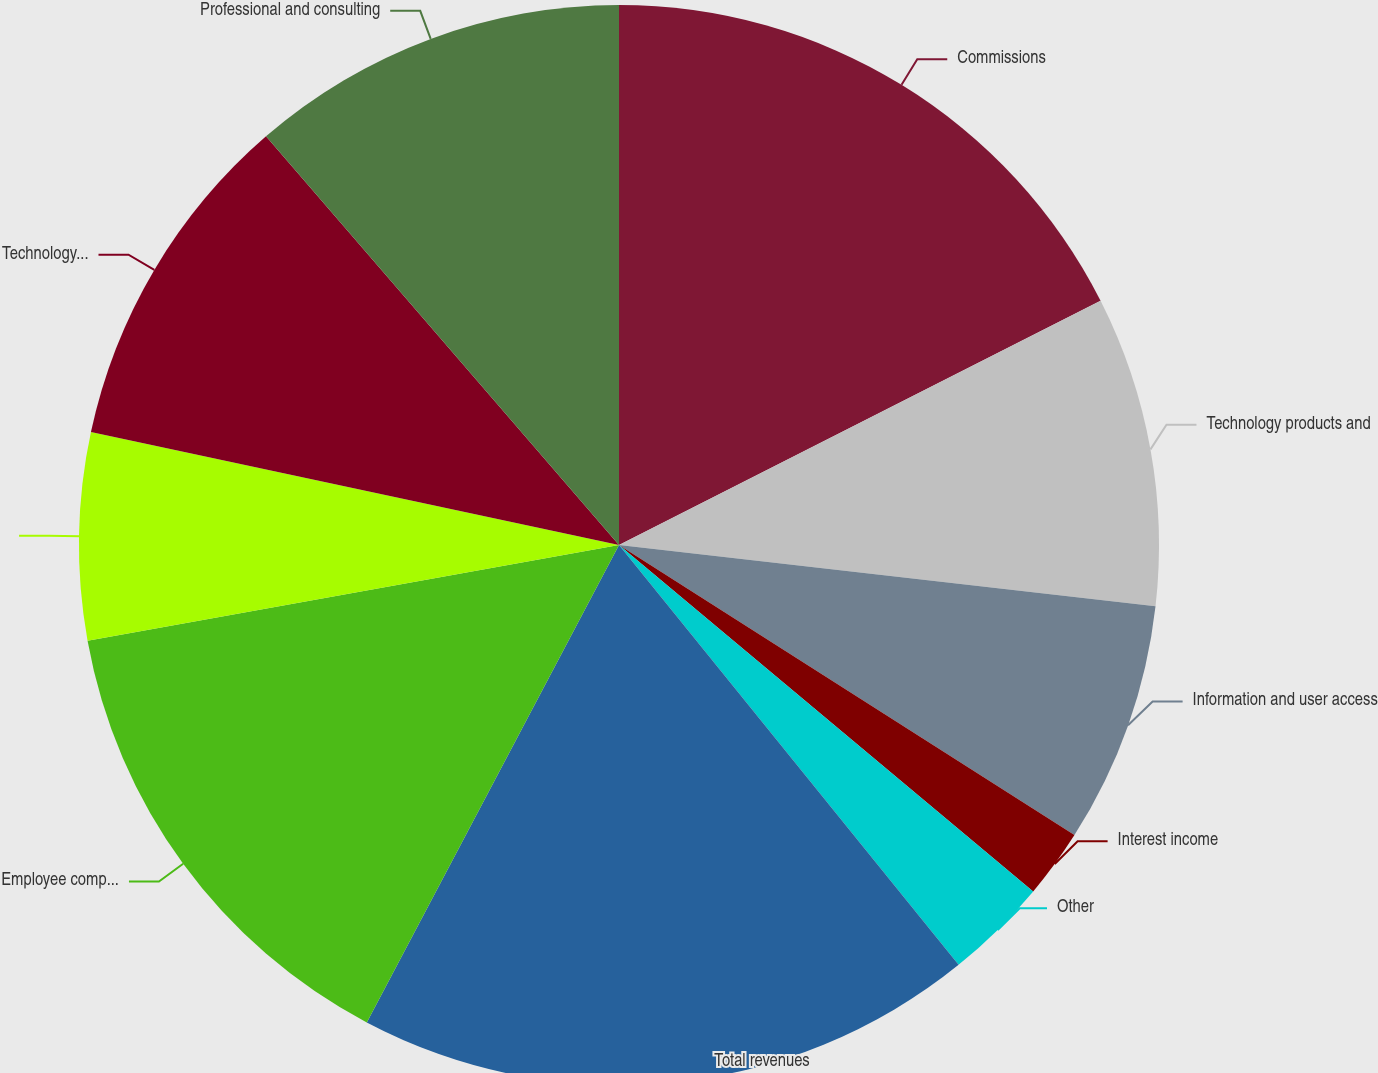Convert chart to OTSL. <chart><loc_0><loc_0><loc_500><loc_500><pie_chart><fcel>Commissions<fcel>Technology products and<fcel>Information and user access<fcel>Interest income<fcel>Other<fcel>Total revenues<fcel>Employee compensation and<fcel>Depreciation and amortization<fcel>Technology and communications<fcel>Professional and consulting<nl><fcel>17.53%<fcel>9.28%<fcel>7.22%<fcel>2.06%<fcel>3.09%<fcel>18.56%<fcel>14.43%<fcel>6.19%<fcel>10.31%<fcel>11.34%<nl></chart> 